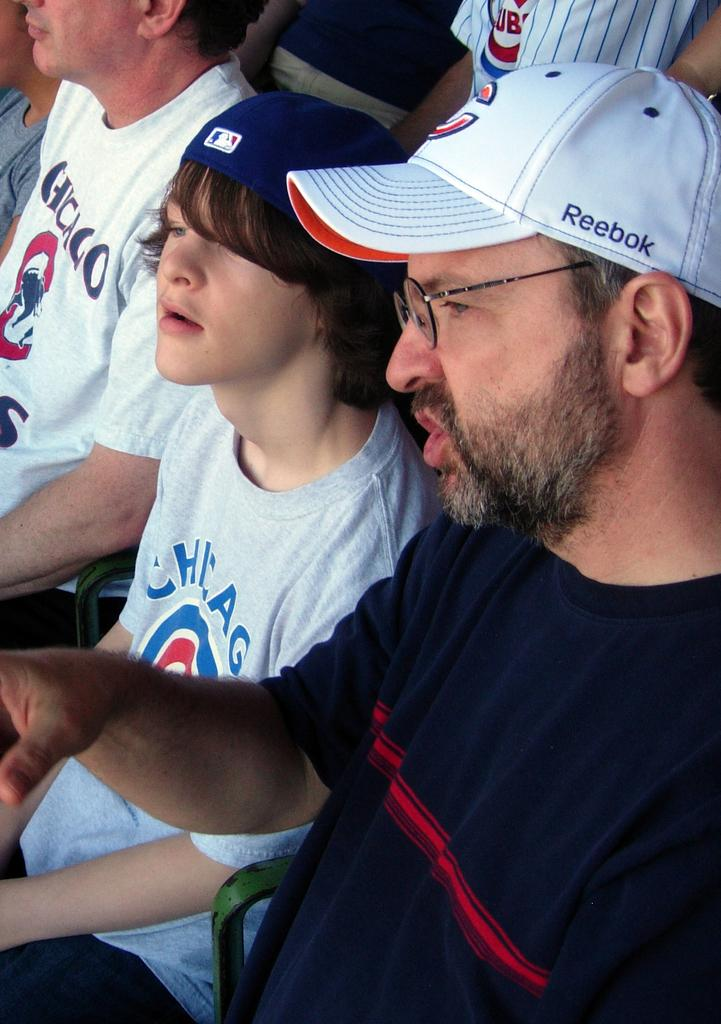<image>
Offer a succinct explanation of the picture presented. A man wearing a Reebok hat sits next to a boy wearing a Chicago shirt in a crowd at a sports arena. 